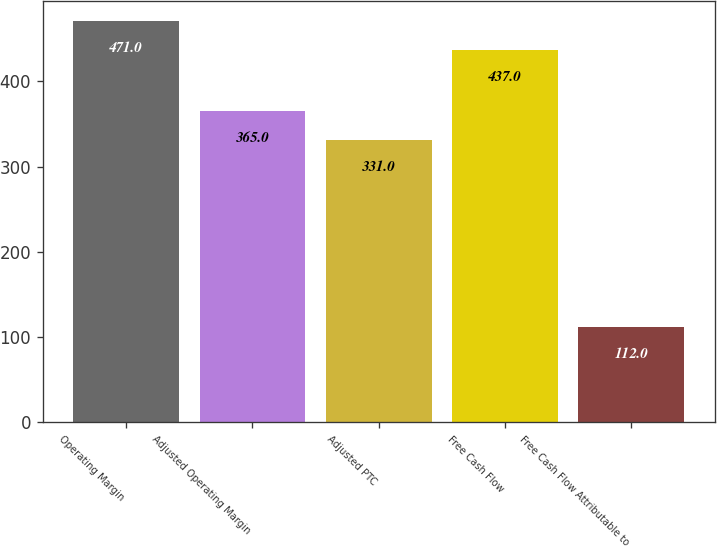Convert chart. <chart><loc_0><loc_0><loc_500><loc_500><bar_chart><fcel>Operating Margin<fcel>Adjusted Operating Margin<fcel>Adjusted PTC<fcel>Free Cash Flow<fcel>Free Cash Flow Attributable to<nl><fcel>471<fcel>365<fcel>331<fcel>437<fcel>112<nl></chart> 